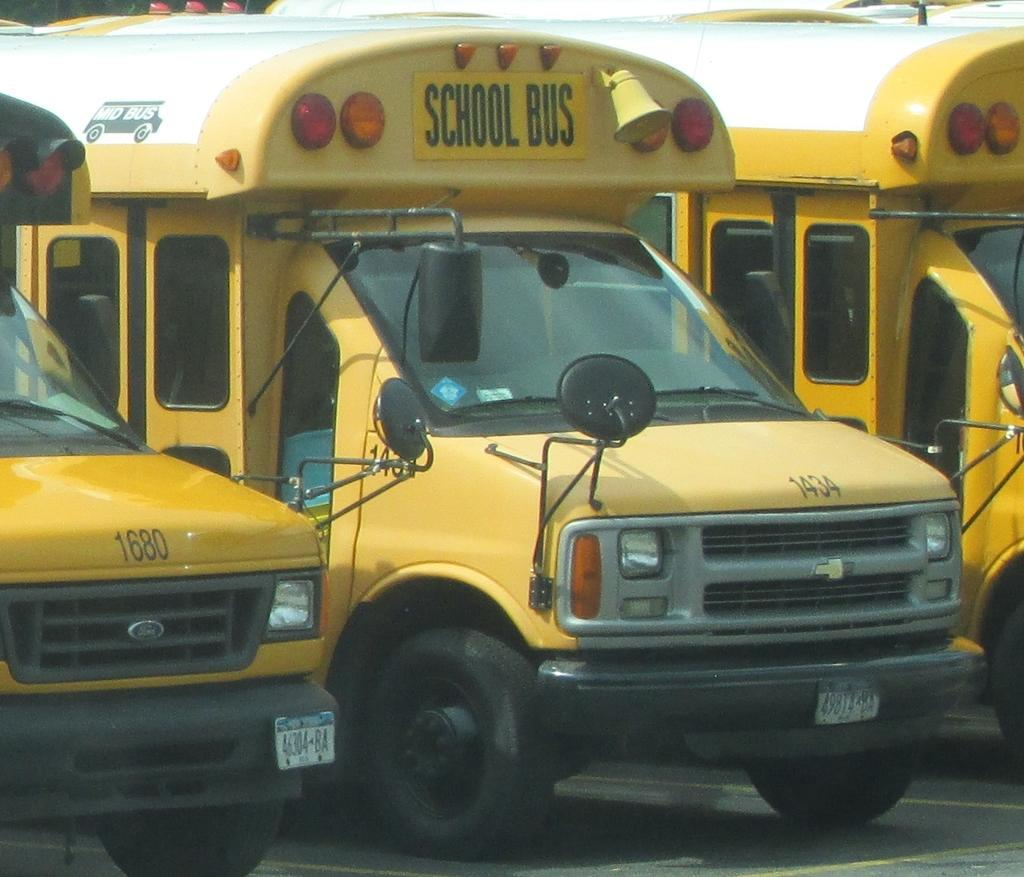Provide a one-sentence caption for the provided image. Numbered yellow school buses are parked side by side, with 1680 a neighbor to 1434. 